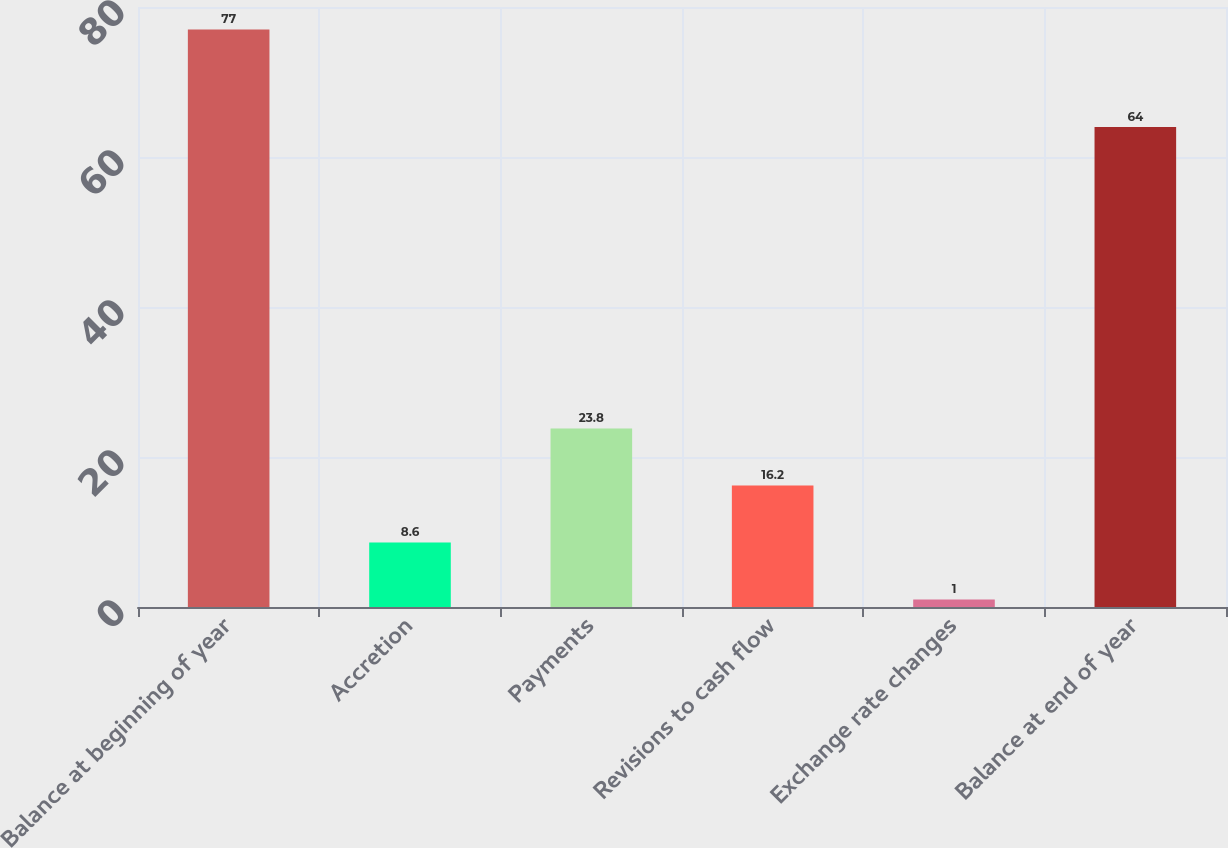Convert chart. <chart><loc_0><loc_0><loc_500><loc_500><bar_chart><fcel>Balance at beginning of year<fcel>Accretion<fcel>Payments<fcel>Revisions to cash flow<fcel>Exchange rate changes<fcel>Balance at end of year<nl><fcel>77<fcel>8.6<fcel>23.8<fcel>16.2<fcel>1<fcel>64<nl></chart> 